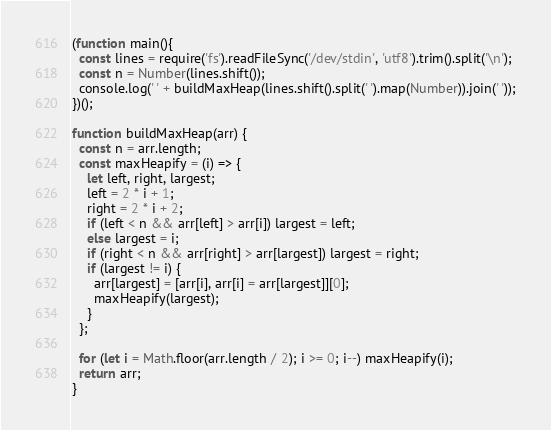<code> <loc_0><loc_0><loc_500><loc_500><_JavaScript_>(function main(){
  const lines = require('fs').readFileSync('/dev/stdin', 'utf8').trim().split('\n');
  const n = Number(lines.shift());
  console.log(' ' + buildMaxHeap(lines.shift().split(' ').map(Number)).join(' '));
})();

function buildMaxHeap(arr) {
  const n = arr.length;
  const maxHeapify = (i) => {
    let left, right, largest;
    left = 2 * i + 1;
    right = 2 * i + 2;
    if (left < n && arr[left] > arr[i]) largest = left;
    else largest = i;
    if (right < n && arr[right] > arr[largest]) largest = right;
    if (largest != i) {
      arr[largest] = [arr[i], arr[i] = arr[largest]][0];
      maxHeapify(largest);
    }
  };

  for (let i = Math.floor(arr.length / 2); i >= 0; i--) maxHeapify(i);
  return arr;
}

</code> 